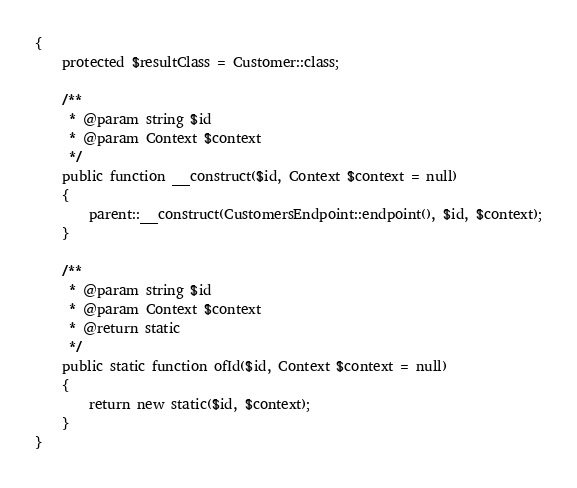Convert code to text. <code><loc_0><loc_0><loc_500><loc_500><_PHP_>{
    protected $resultClass = Customer::class;

    /**
     * @param string $id
     * @param Context $context
     */
    public function __construct($id, Context $context = null)
    {
        parent::__construct(CustomersEndpoint::endpoint(), $id, $context);
    }

    /**
     * @param string $id
     * @param Context $context
     * @return static
     */
    public static function ofId($id, Context $context = null)
    {
        return new static($id, $context);
    }
}
</code> 